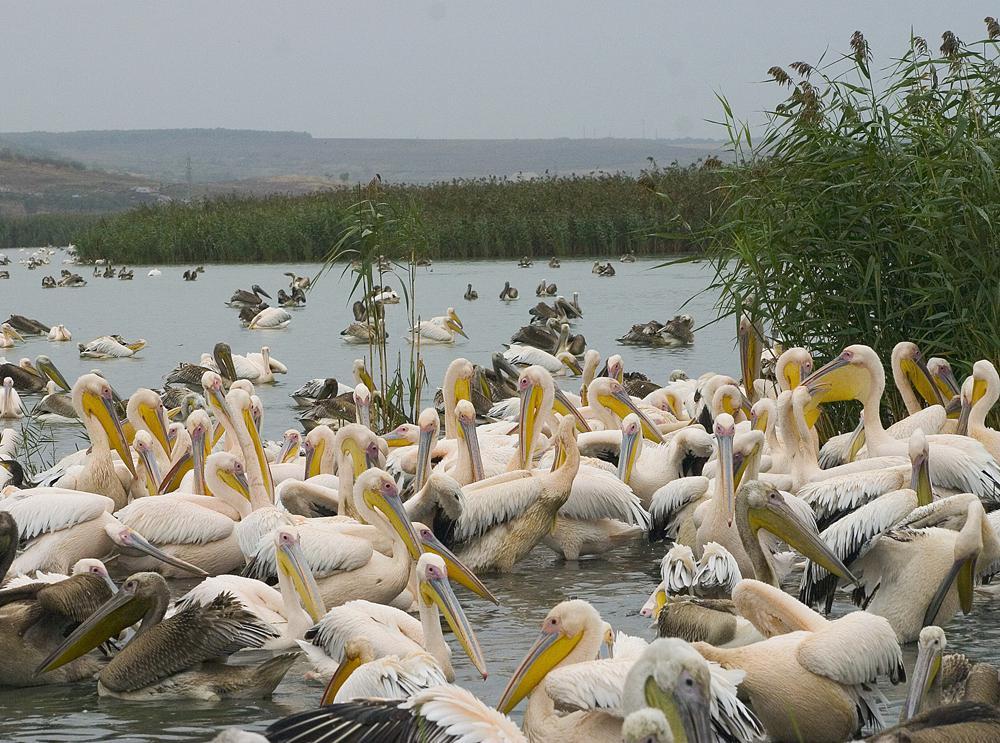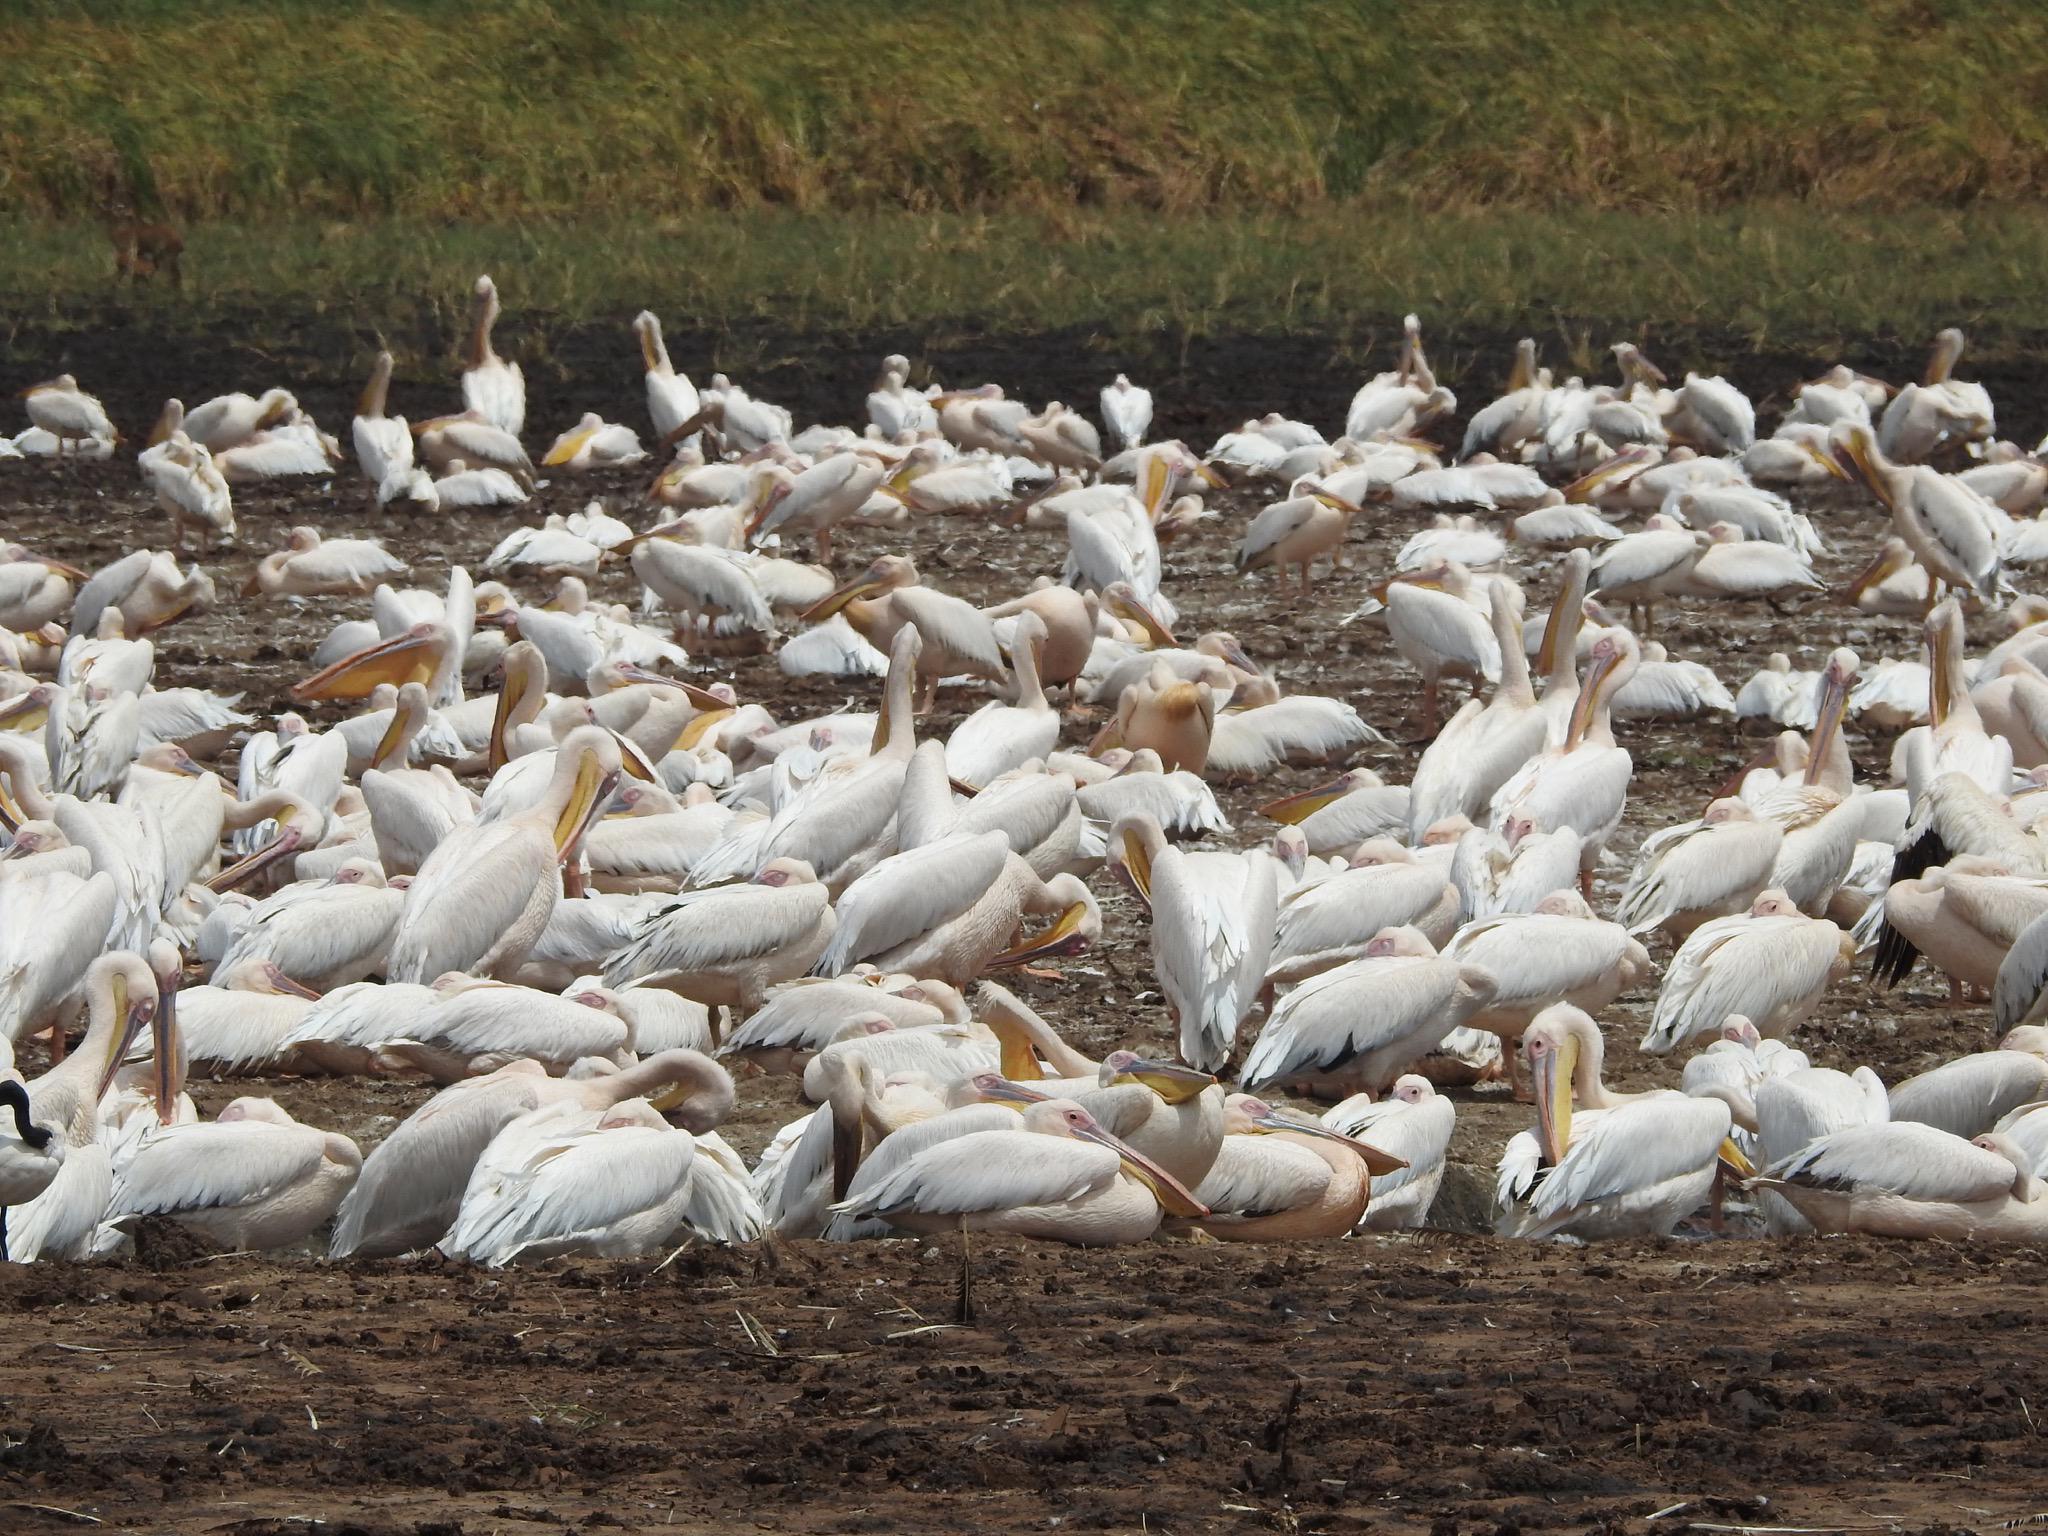The first image is the image on the left, the second image is the image on the right. Given the left and right images, does the statement "In one image, nearly all pelicans in the foreground face leftward." hold true? Answer yes or no. No. The first image is the image on the left, the second image is the image on the right. Analyze the images presented: Is the assertion "A few of the birds are in the air in one one the images." valid? Answer yes or no. No. 